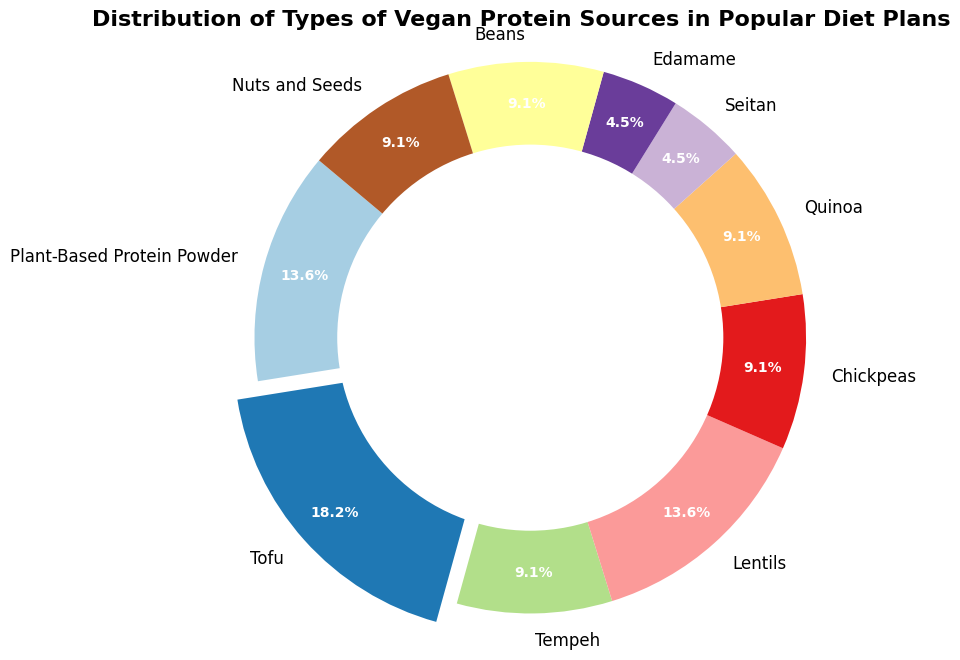What's the largest percentage of vegan protein sources? The figure shows various slices of a pie chart representing different vegan protein sources and their percentages. The largest slice is "Tofu", and it is also visually exploded for emphasis, with a percentage of 20%.
Answer: 20% Which vegan protein sources have the same percentage? The pie chart lists multiple sources along with their percentages. By comparing these values, we can see "Lentils", "Beans", and "Nuts and Seeds" all have a percentage of 10%.
Answer: Lentils, Beans, Nuts and Seeds Is there any smaller category than Seitan? By examining the pie chart, Seitan is represented with a percentage of 5%. It's one of the smallest but there is no category smaller than 5%.
Answer: No What's the combined percentage of Tofu and Plant-Based Protein Powder? Tofu has a percentage of 20% and Plant-Based Protein Powder has 15%. Adding these, 20% + 15% = 35%.
Answer: 35% How does the percentage of Quinoa compare to Edamame? In the pie chart, both Quinoa and Edamame are represented with the same percentage of 10%.
Answer: Equal What is the percentage difference between the largest and smallest slices? The largest slice is Tofu with 20%, and the smallest slices are Seitan and Edamame with 5%. The difference is 20% - 5% = 15%.
Answer: 15% Which source occupies 10% of the chart? A quick look at the chart reveals that several sources occupy 10% each, namely Tempeh, Chickpeas, Quinoa, Beans, and Nuts and Seeds.
Answer: Tempeh, Chickpeas, Quinoa, Beans, Nuts and Seeds What is the total percentage of sources that are represented as 15%? The chart shows Plant-Based Protein Powder and Lentils, each with a slice of 15%, so their combined percentage is 15% + 15% = 30%.
Answer: 30% What is the visual characteristic used to highlight the most significant segment? The most significant segment (Tofu) is visually highlighted by being slightly "exploded" or separated from the rest of the pie chart, making it stand out.
Answer: Exploded pie slice 